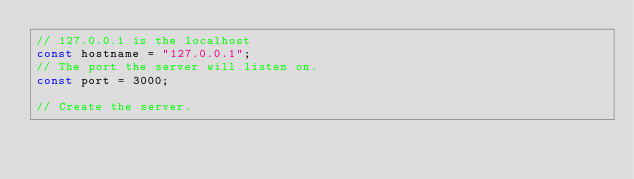<code> <loc_0><loc_0><loc_500><loc_500><_JavaScript_>// 127.0.0.1 is the localhost
const hostname = "127.0.0.1";
// The port the server will listen on.
const port = 3000;

// Create the server.</code> 